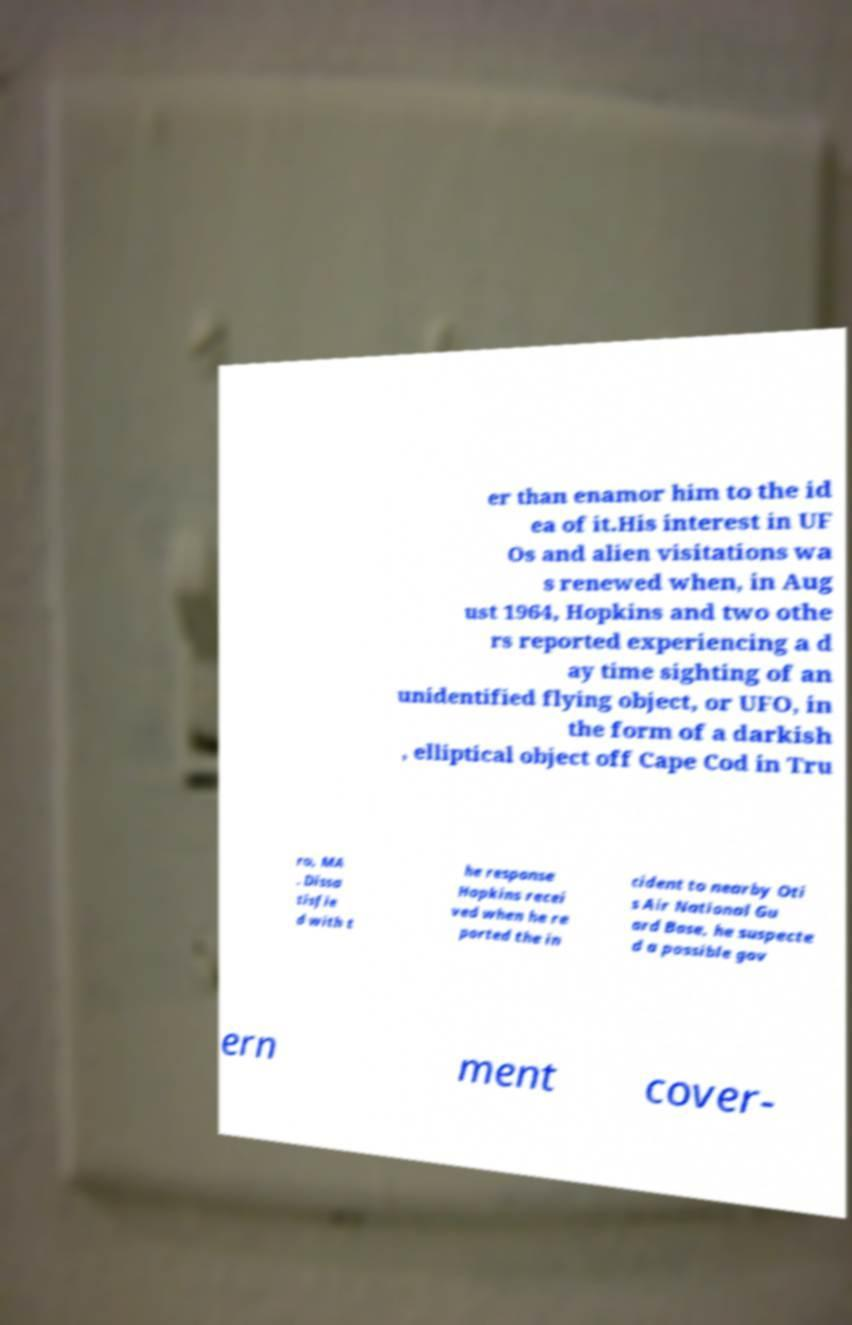Could you extract and type out the text from this image? er than enamor him to the id ea of it.His interest in UF Os and alien visitations wa s renewed when, in Aug ust 1964, Hopkins and two othe rs reported experiencing a d ay time sighting of an unidentified flying object, or UFO, in the form of a darkish , elliptical object off Cape Cod in Tru ro, MA . Dissa tisfie d with t he response Hopkins recei ved when he re ported the in cident to nearby Oti s Air National Gu ard Base, he suspecte d a possible gov ern ment cover- 